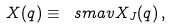<formula> <loc_0><loc_0><loc_500><loc_500>X ( q ) \equiv \ s m a v { X _ { J } ( q ) } \, ,</formula> 